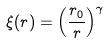Convert formula to latex. <formula><loc_0><loc_0><loc_500><loc_500>\xi ( r ) = \left ( \frac { r _ { 0 } } { r } \right ) ^ { \gamma }</formula> 